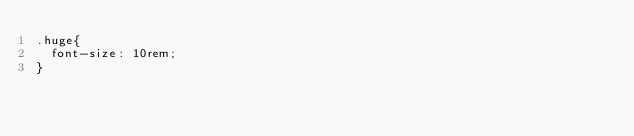Convert code to text. <code><loc_0><loc_0><loc_500><loc_500><_CSS_>.huge{
  font-size: 10rem;
}
</code> 